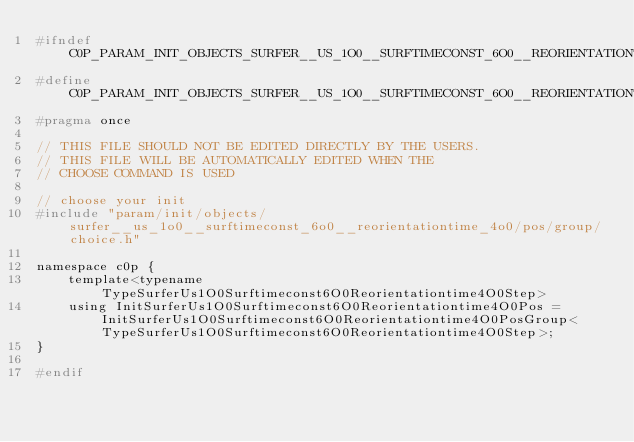Convert code to text. <code><loc_0><loc_0><loc_500><loc_500><_C_>#ifndef C0P_PARAM_INIT_OBJECTS_SURFER__US_1O0__SURFTIMECONST_6O0__REORIENTATIONTIME_4O0_POS_CHOICE_H
#define C0P_PARAM_INIT_OBJECTS_SURFER__US_1O0__SURFTIMECONST_6O0__REORIENTATIONTIME_4O0_POS_CHOICE_H
#pragma once

// THIS FILE SHOULD NOT BE EDITED DIRECTLY BY THE USERS.
// THIS FILE WILL BE AUTOMATICALLY EDITED WHEN THE
// CHOOSE COMMAND IS USED

// choose your init
#include "param/init/objects/surfer__us_1o0__surftimeconst_6o0__reorientationtime_4o0/pos/group/choice.h"

namespace c0p {
    template<typename TypeSurferUs1O0Surftimeconst6O0Reorientationtime4O0Step>
    using InitSurferUs1O0Surftimeconst6O0Reorientationtime4O0Pos = InitSurferUs1O0Surftimeconst6O0Reorientationtime4O0PosGroup<TypeSurferUs1O0Surftimeconst6O0Reorientationtime4O0Step>;
}

#endif
</code> 